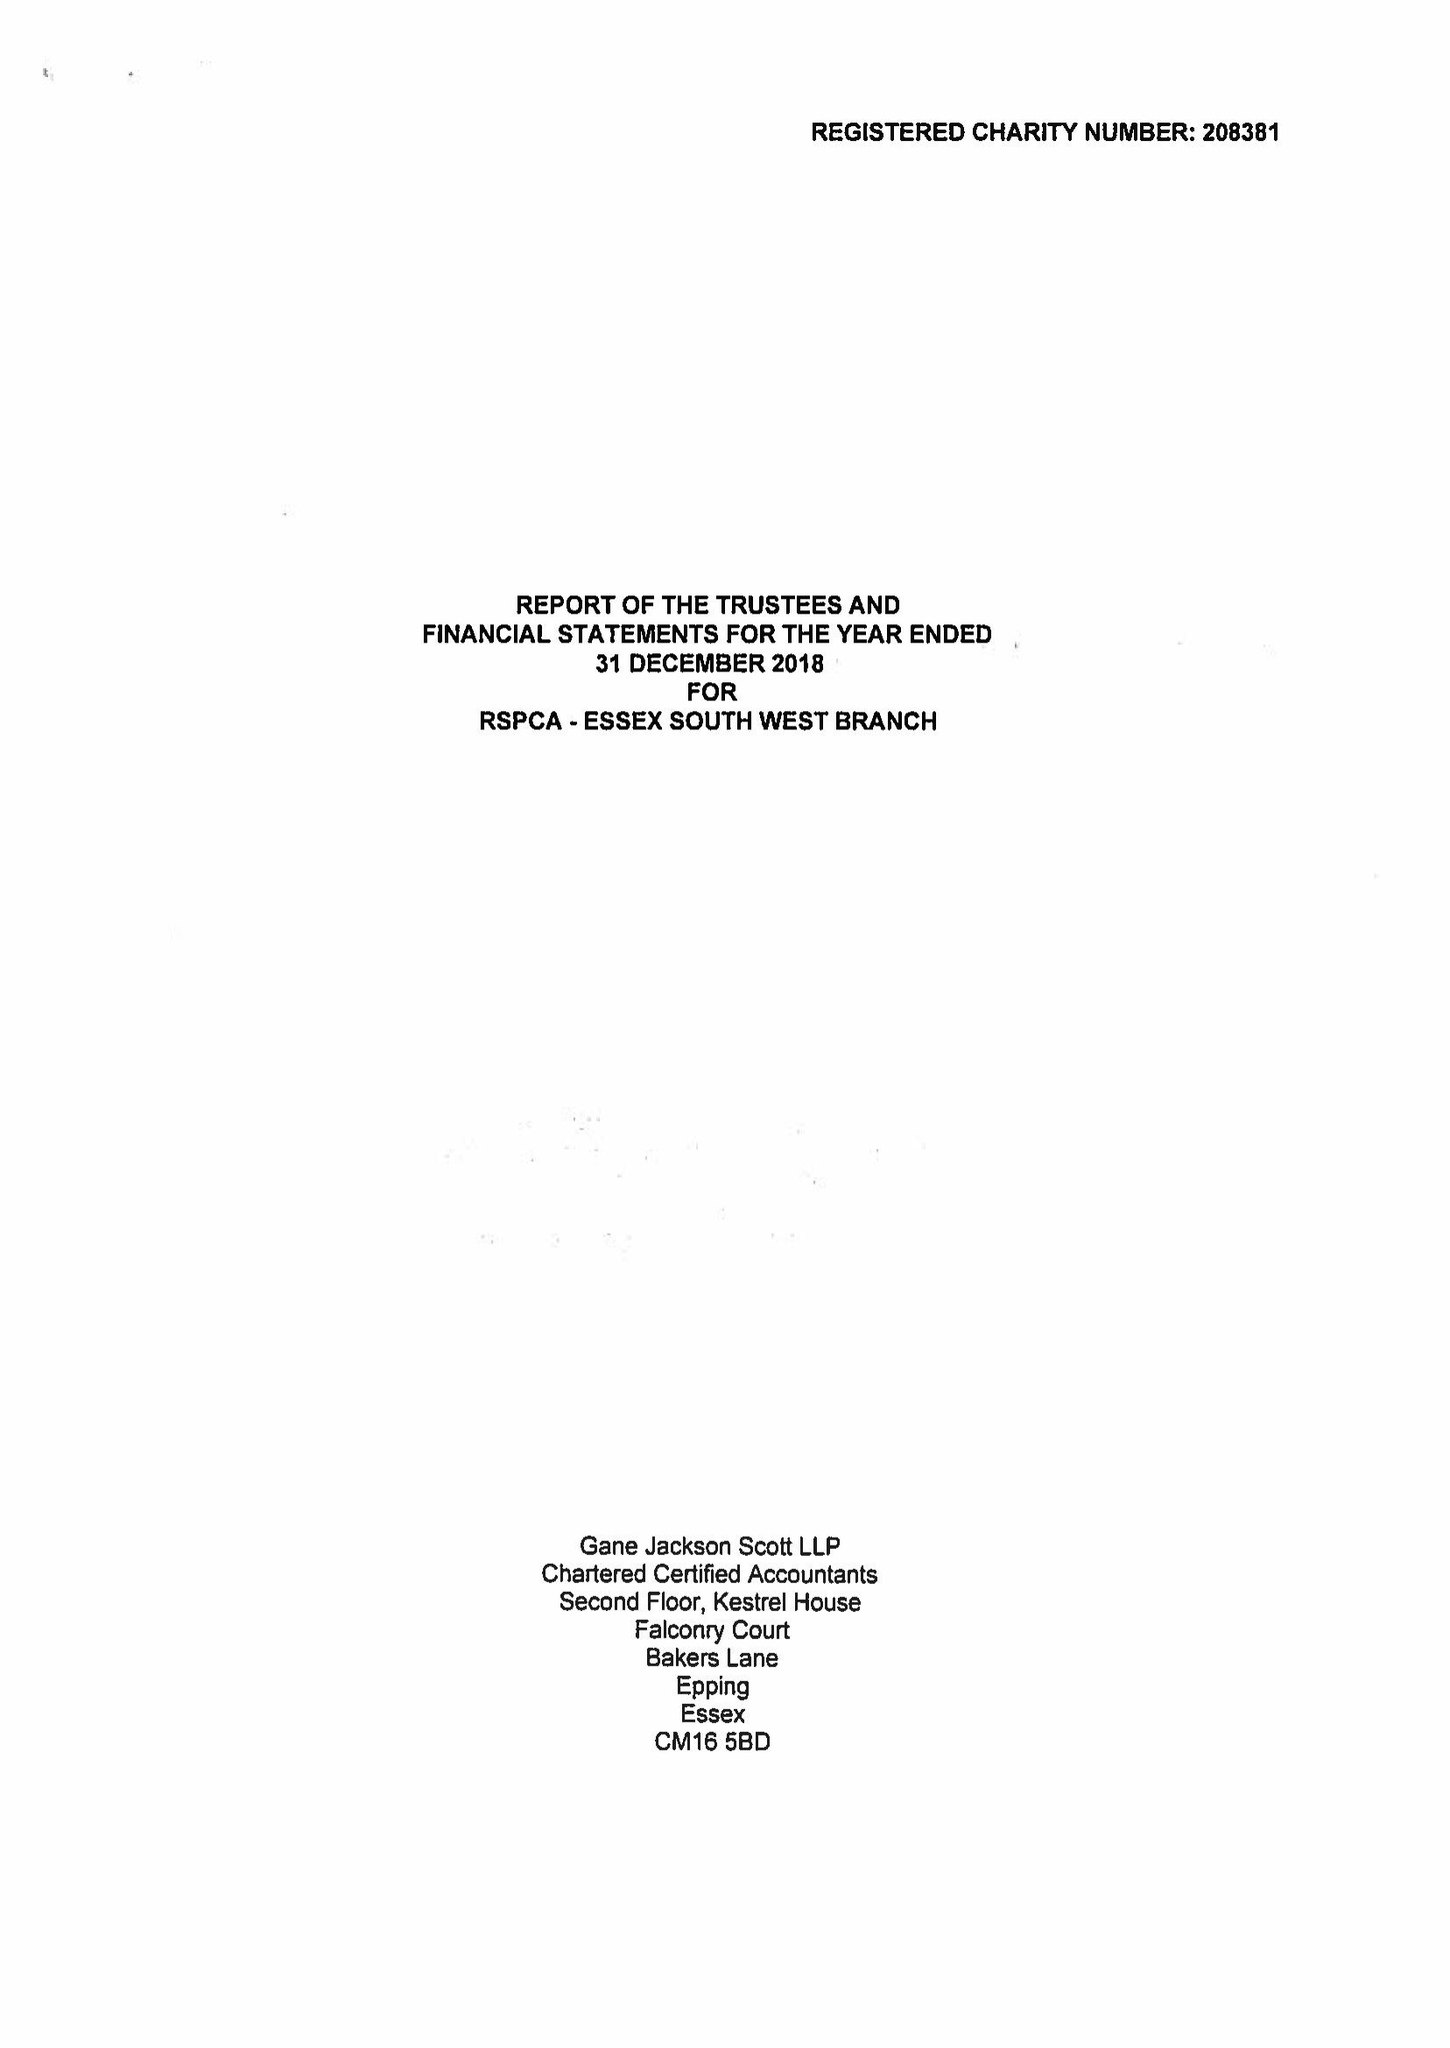What is the value for the charity_number?
Answer the question using a single word or phrase. 208381 